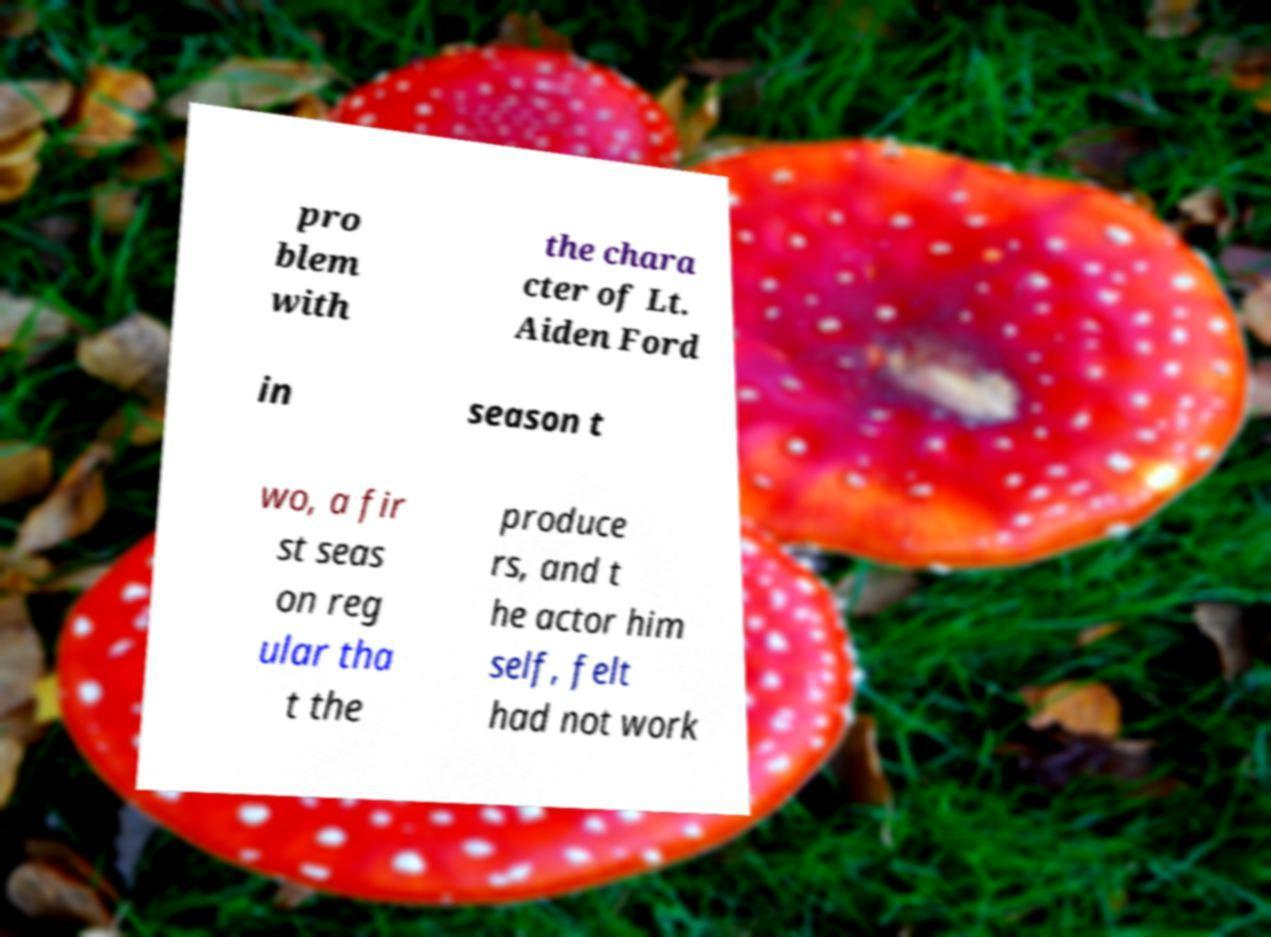Can you accurately transcribe the text from the provided image for me? pro blem with the chara cter of Lt. Aiden Ford in season t wo, a fir st seas on reg ular tha t the produce rs, and t he actor him self, felt had not work 